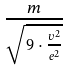Convert formula to latex. <formula><loc_0><loc_0><loc_500><loc_500>\frac { m } { \sqrt { 9 \cdot \frac { v ^ { 2 } } { e ^ { 2 } } } }</formula> 